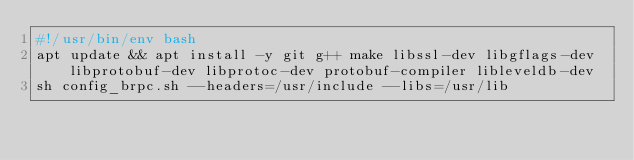<code> <loc_0><loc_0><loc_500><loc_500><_Bash_>#!/usr/bin/env bash
apt update && apt install -y git g++ make libssl-dev libgflags-dev libprotobuf-dev libprotoc-dev protobuf-compiler libleveldb-dev
sh config_brpc.sh --headers=/usr/include --libs=/usr/lib
</code> 